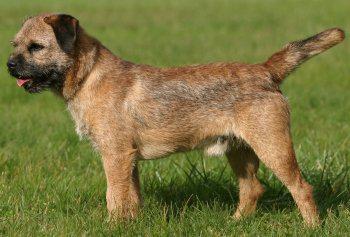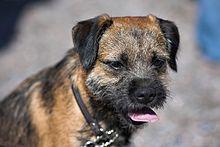The first image is the image on the left, the second image is the image on the right. Given the left and right images, does the statement "At least one of the dogs has its tongue sticking out." hold true? Answer yes or no. Yes. 